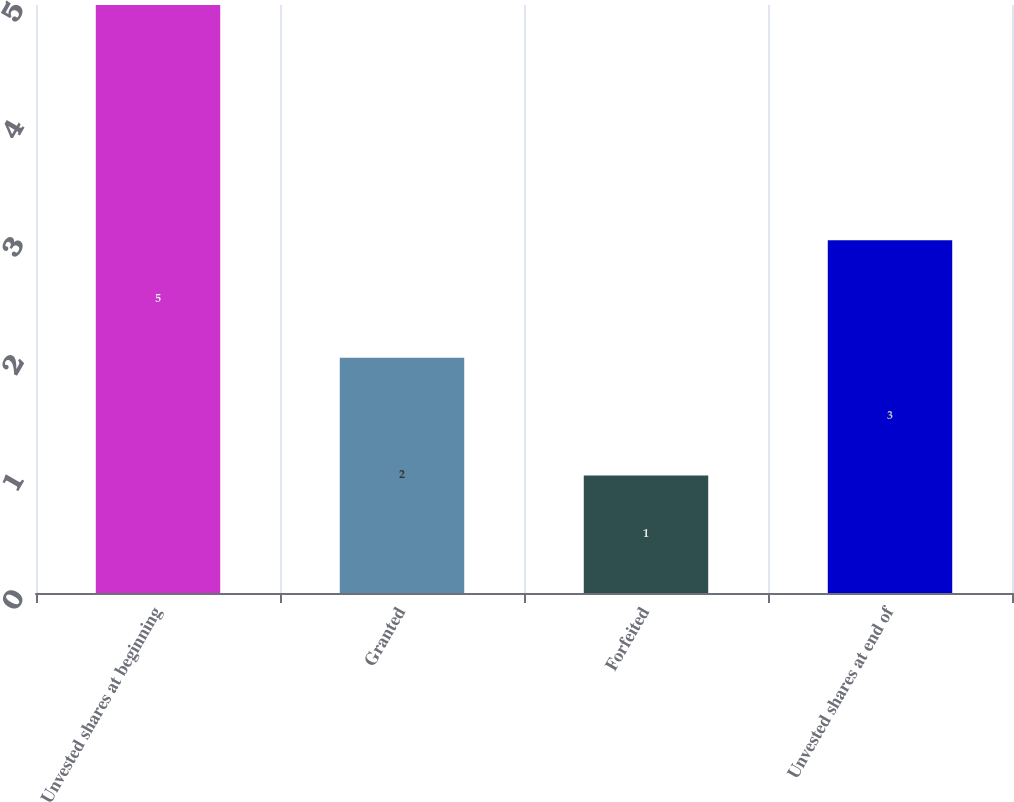Convert chart. <chart><loc_0><loc_0><loc_500><loc_500><bar_chart><fcel>Unvested shares at beginning<fcel>Granted<fcel>Forfeited<fcel>Unvested shares at end of<nl><fcel>5<fcel>2<fcel>1<fcel>3<nl></chart> 